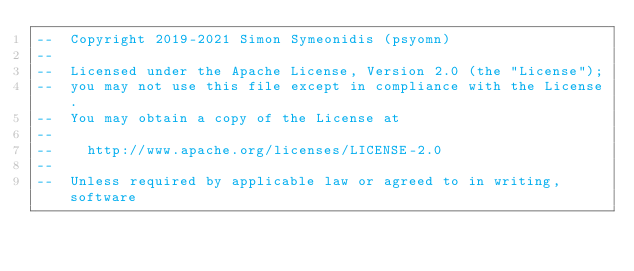<code> <loc_0><loc_0><loc_500><loc_500><_Ada_>--  Copyright 2019-2021 Simon Symeonidis (psyomn)
--
--  Licensed under the Apache License, Version 2.0 (the "License");
--  you may not use this file except in compliance with the License.
--  You may obtain a copy of the License at
--
--    http://www.apache.org/licenses/LICENSE-2.0
--
--  Unless required by applicable law or agreed to in writing, software</code> 